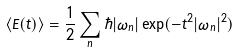Convert formula to latex. <formula><loc_0><loc_0><loc_500><loc_500>\langle E ( t ) \rangle = { \frac { 1 } { 2 } } \sum _ { n } \hbar { | } \omega _ { n } | \exp ( - t ^ { 2 } | \omega _ { n } | ^ { 2 } )</formula> 